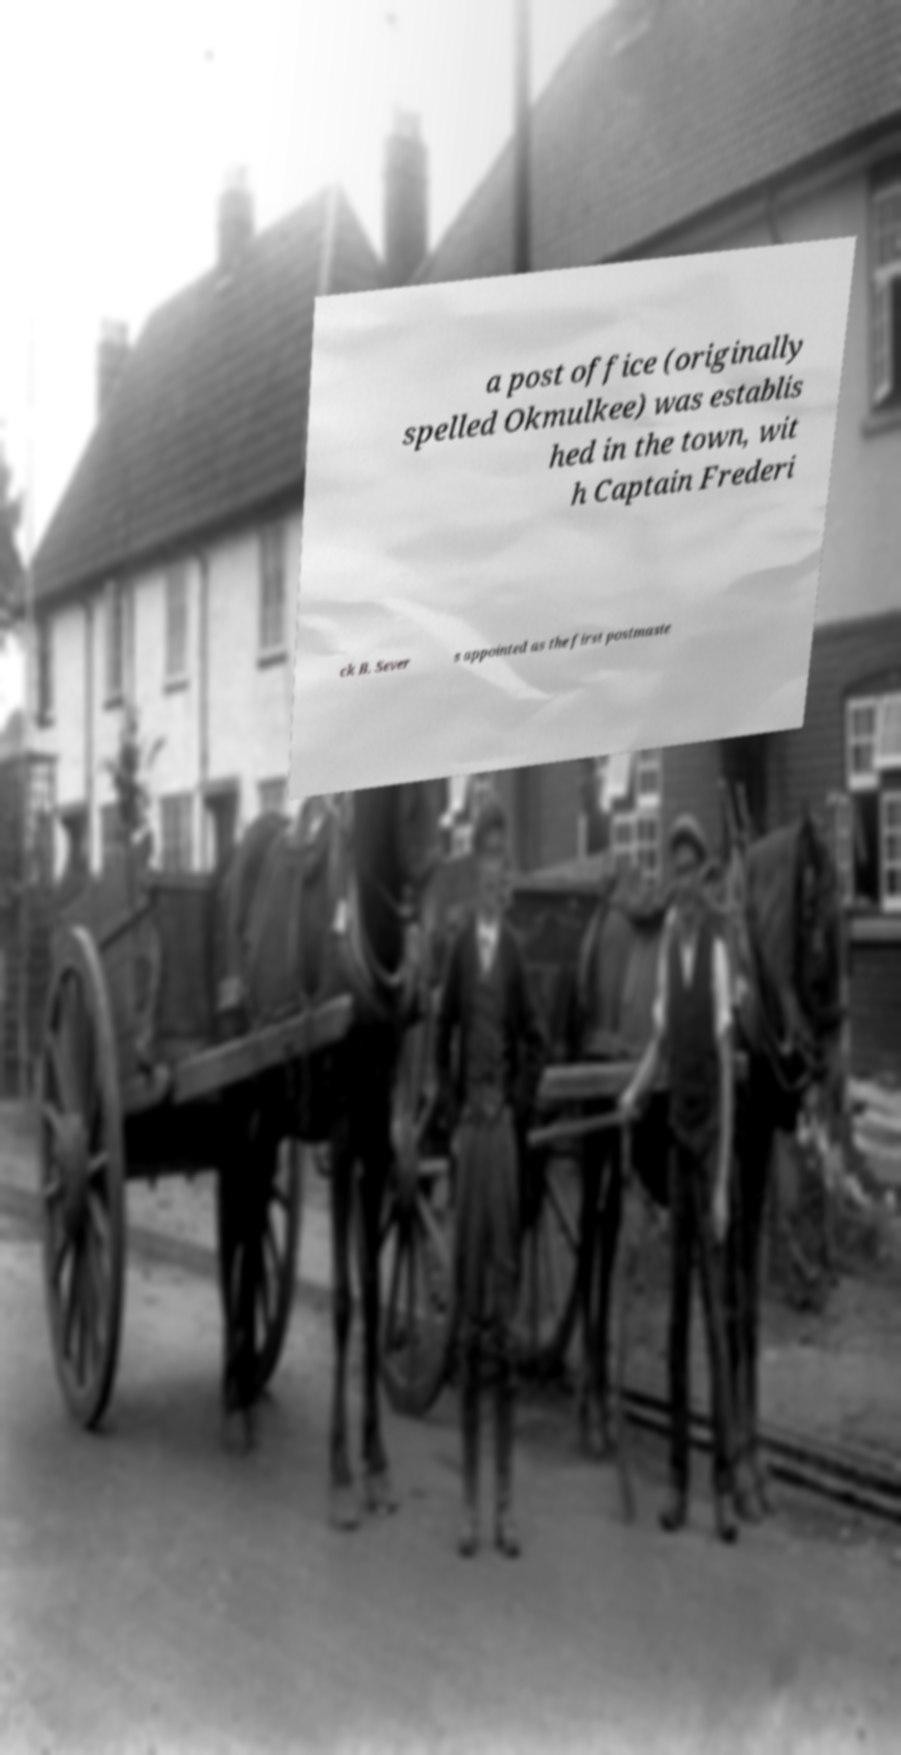For documentation purposes, I need the text within this image transcribed. Could you provide that? a post office (originally spelled Okmulkee) was establis hed in the town, wit h Captain Frederi ck B. Sever s appointed as the first postmaste 